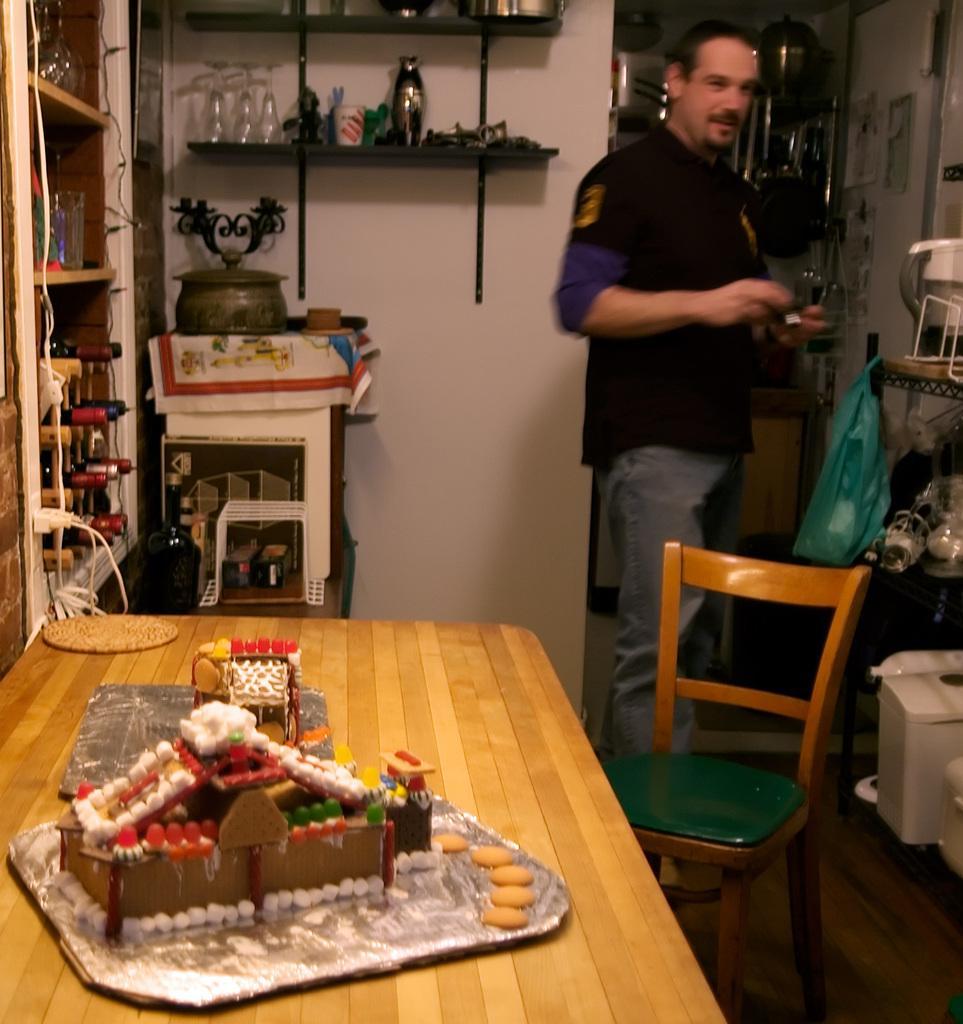Could you give a brief overview of what you see in this image? There are some objects placed on the table and there is a person standing in the right corner. 